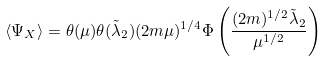Convert formula to latex. <formula><loc_0><loc_0><loc_500><loc_500>\langle \Psi _ { X } \rangle = \theta ( \mu ) \theta ( \tilde { \lambda } _ { 2 } ) ( 2 m \mu ) ^ { 1 / 4 } \Phi \left ( \frac { ( 2 m ) ^ { 1 / 2 } \tilde { \lambda } _ { 2 } } { \mu ^ { 1 / 2 } } \right )</formula> 